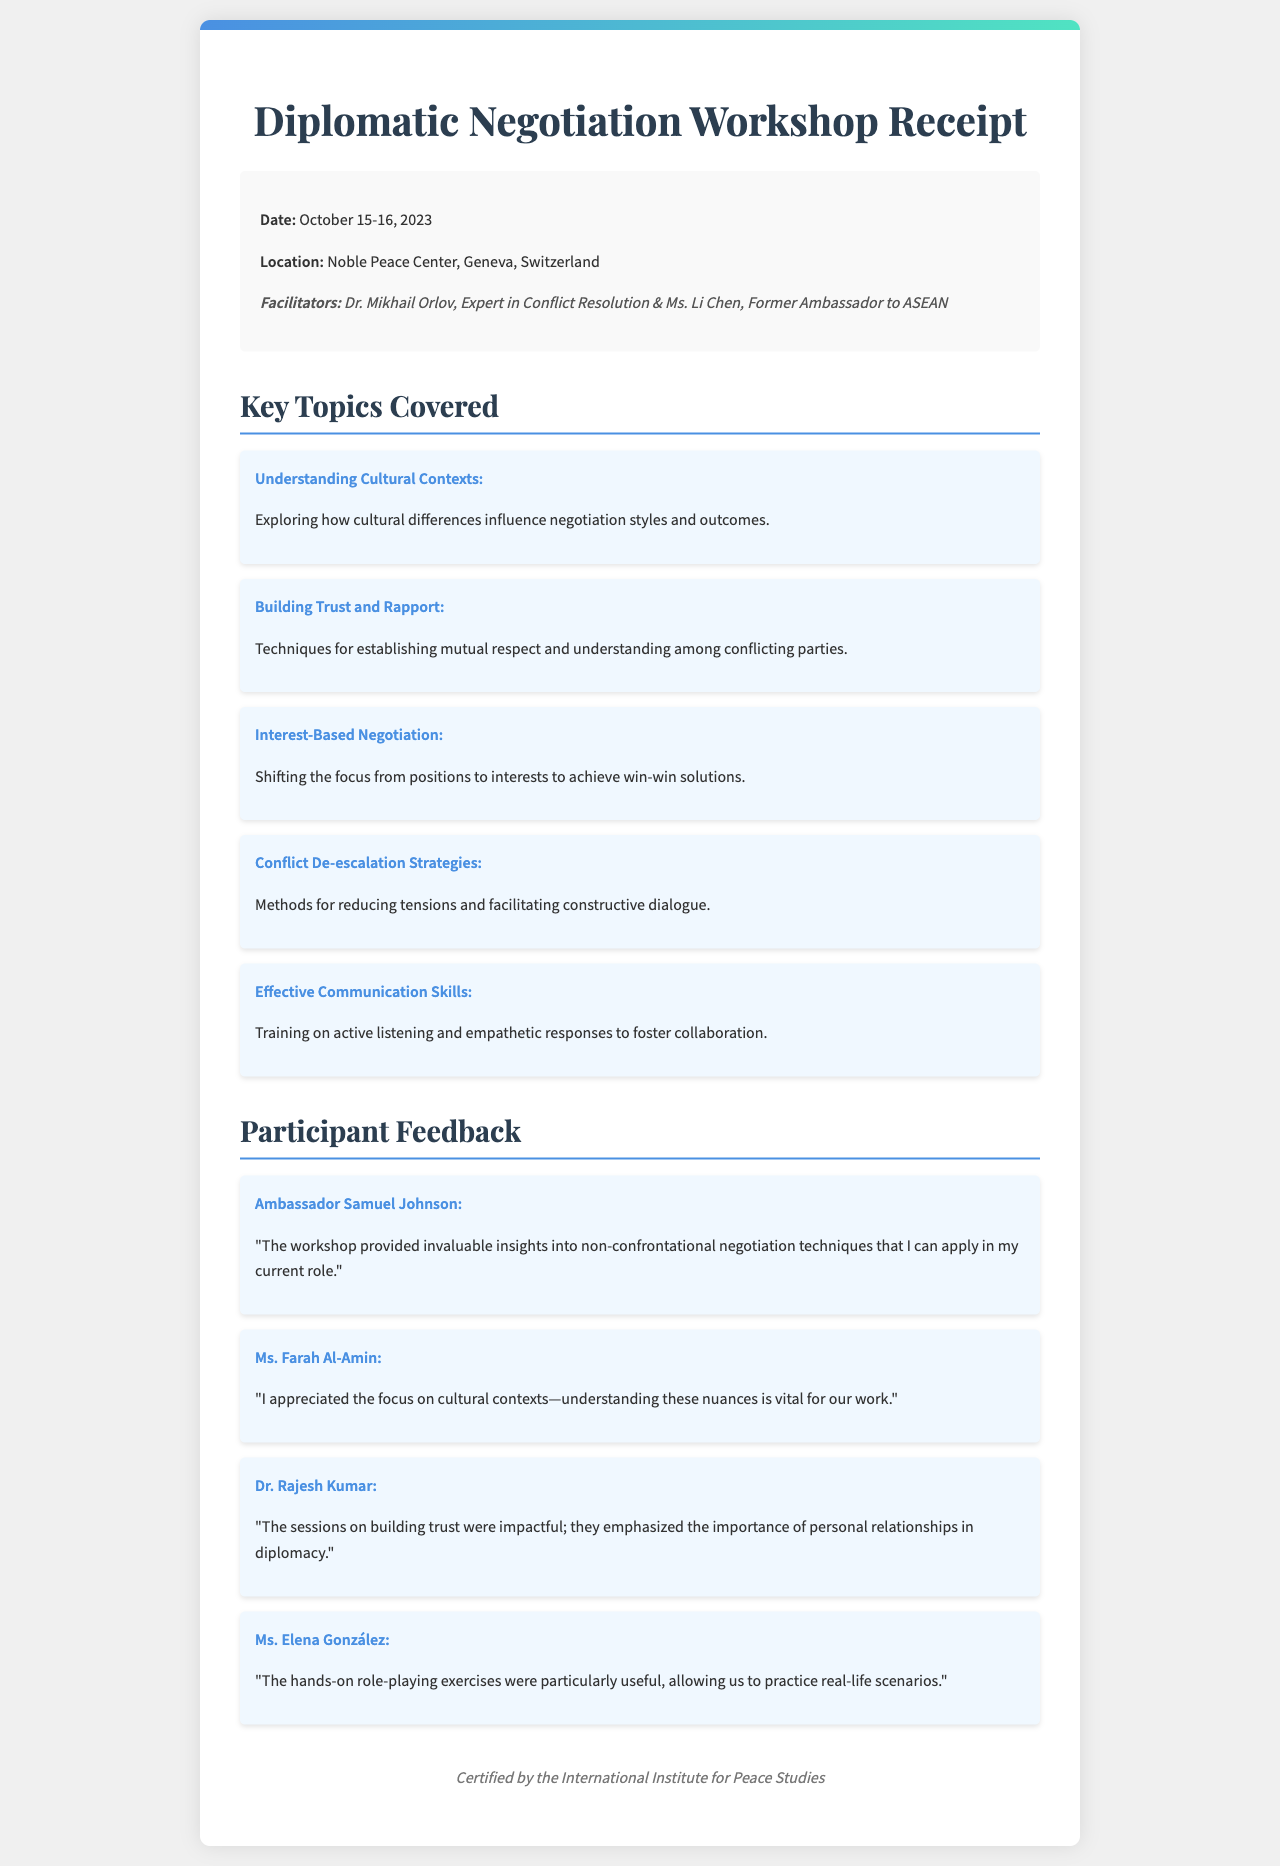What were the dates of the workshop? The dates of the workshop are explicitly mentioned in the document as October 15-16, 2023.
Answer: October 15-16, 2023 Where was the workshop held? The location of the workshop is stated in the document as Noble Peace Center, Geneva, Switzerland.
Answer: Noble Peace Center, Geneva, Switzerland Who facilitated the workshop? The document lists the facilitators, which includes Dr. Mikhail Orlov and Ms. Li Chen.
Answer: Dr. Mikhail Orlov, Ms. Li Chen What is one of the key topics covered about cultural understanding? The specific topic mentioned in the document is how cultural differences influence negotiation styles and outcomes.
Answer: Understanding Cultural Contexts Which strategy was emphasized for reducing tensions? The document describes methods for reducing tensions and facilitating constructive dialogue.
Answer: Conflict De-escalation Strategies Which participant found value in cultural contexts? The feedback from Ms. Farah Al-Amin reflects her appreciation for the focus on cultural contexts.
Answer: Ms. Farah Al-Amin What was the sentiment expressed by Ambassador Samuel Johnson regarding the workshop? His feedback indicates that the workshop provided invaluable insights into non-confrontational negotiation techniques.
Answer: Invaluable insights What type of exercises were noted as particularly useful by participants? The document notes that hands-on role-playing exercises were particularly useful for practicing real-life scenarios.
Answer: Hands-on role-playing exercises What was the certification provided by at the workshop? The document states that the workshop was certified by the International Institute for Peace Studies.
Answer: International Institute for Peace Studies 